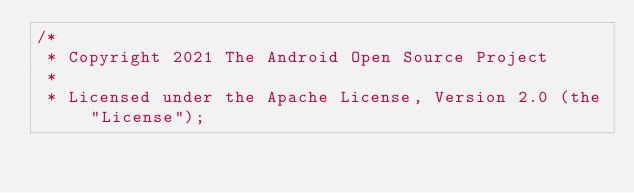<code> <loc_0><loc_0><loc_500><loc_500><_Kotlin_>/*
 * Copyright 2021 The Android Open Source Project
 *
 * Licensed under the Apache License, Version 2.0 (the "License");</code> 